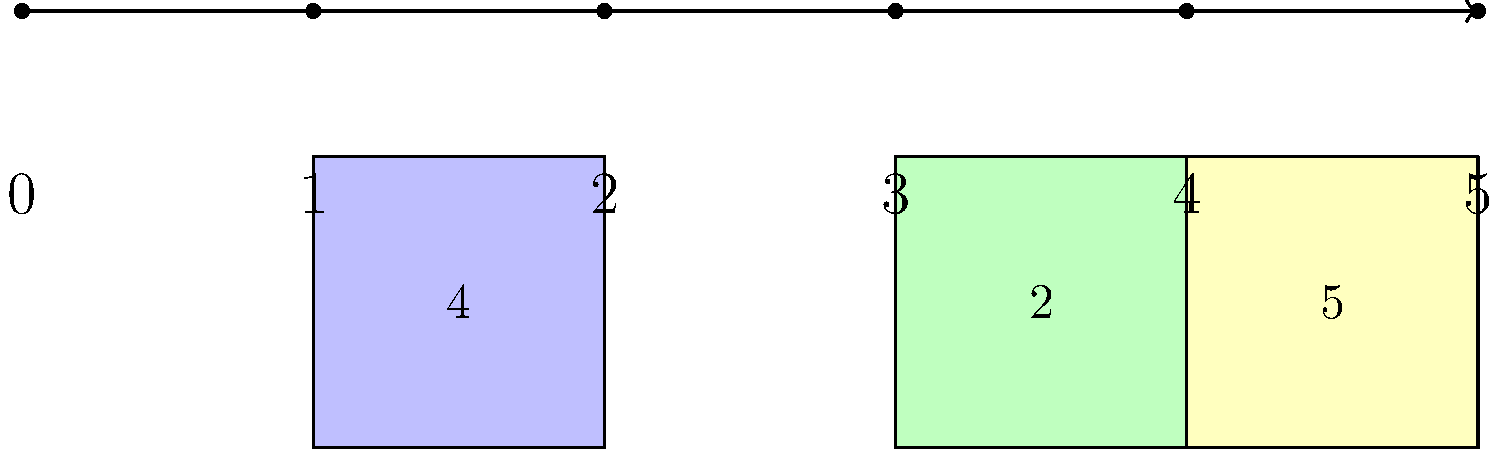In a kindergarten classroom, children are learning to arrange numbers on a number line. Three numbered blocks (4, 2, and 5) are placed on the number line as shown. How many moves are required to arrange these blocks in ascending order? Let's approach this step-by-step:

1. First, we need to identify the current positions of the blocks:
   - Block 4 is in position 1
   - Block 2 is in position 3
   - Block 5 is in position 4

2. Now, let's determine their correct positions in ascending order:
   - Block 2 should be in position 1
   - Block 4 should be in position 3
   - Block 5 is already in the correct position (4)

3. To arrange them correctly, we need to:
   - Move block 2 from position 3 to position 1 (1 move)
   - Move block 4 from position 1 to position 3 (1 move)
   - Block 5 doesn't need to move

4. Count the total number of moves:
   1 (for block 2) + 1 (for block 4) = 2 moves

This approach minimizes the number of moves while achieving the correct ascending order.
Answer: 2 moves 